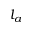Convert formula to latex. <formula><loc_0><loc_0><loc_500><loc_500>l _ { a }</formula> 